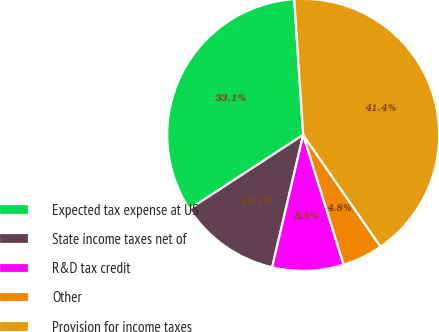Convert chart to OTSL. <chart><loc_0><loc_0><loc_500><loc_500><pie_chart><fcel>Expected tax expense at US<fcel>State income taxes net of<fcel>R&D tax credit<fcel>Other<fcel>Provision for income taxes<nl><fcel>33.15%<fcel>12.14%<fcel>8.48%<fcel>4.82%<fcel>41.42%<nl></chart> 